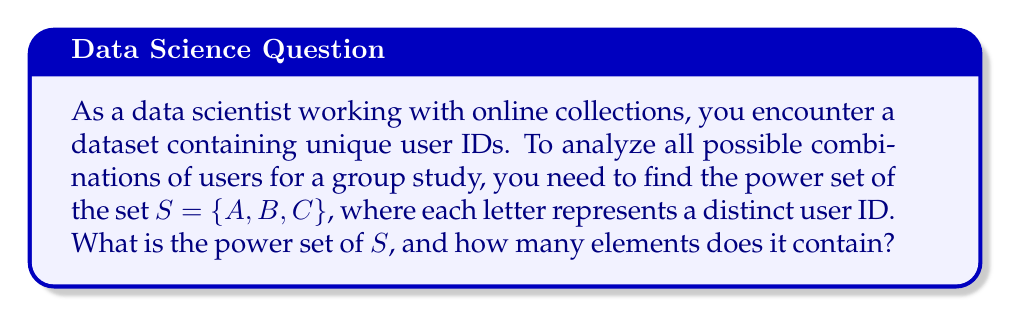Teach me how to tackle this problem. To solve this problem, let's follow these steps:

1) The power set of a set $S$ is the set of all subsets of $S$, including the empty set and $S$ itself.

2) For a set with $n$ elements, the power set contains $2^n$ elements.

3) In this case, $S = \{A, B, C\}$ has 3 elements, so its power set will have $2^3 = 8$ elements.

4) To list all elements of the power set, we can systematically write out all possible combinations:

   - The empty set: $\{\}$
   - Sets with one element: $\{A\}$, $\{B\}$, $\{C\}$
   - Sets with two elements: $\{A,B\}$, $\{A,C\}$, $\{B,C\}$
   - The set itself: $\{A,B,C\}$

5) Therefore, the power set of $S$, which we can denote as $P(S)$, is:

   $P(S) = \{\{\}, \{A\}, \{B\}, \{C\}, \{A,B\}, \{A,C\}, \{B,C\}, \{A,B,C\}\}$

6) We can verify that this power set indeed contains $2^3 = 8$ elements.

This power set represents all possible combinations of users for your group study, ranging from no users (empty set) to all users (the full set $S$).
Answer: The power set of $S = \{A, B, C\}$ is:

$P(S) = \{\{\}, \{A\}, \{B\}, \{C\}, \{A,B\}, \{A,C\}, \{B,C\}, \{A,B,C\}\}$

It contains $2^3 = 8$ elements. 